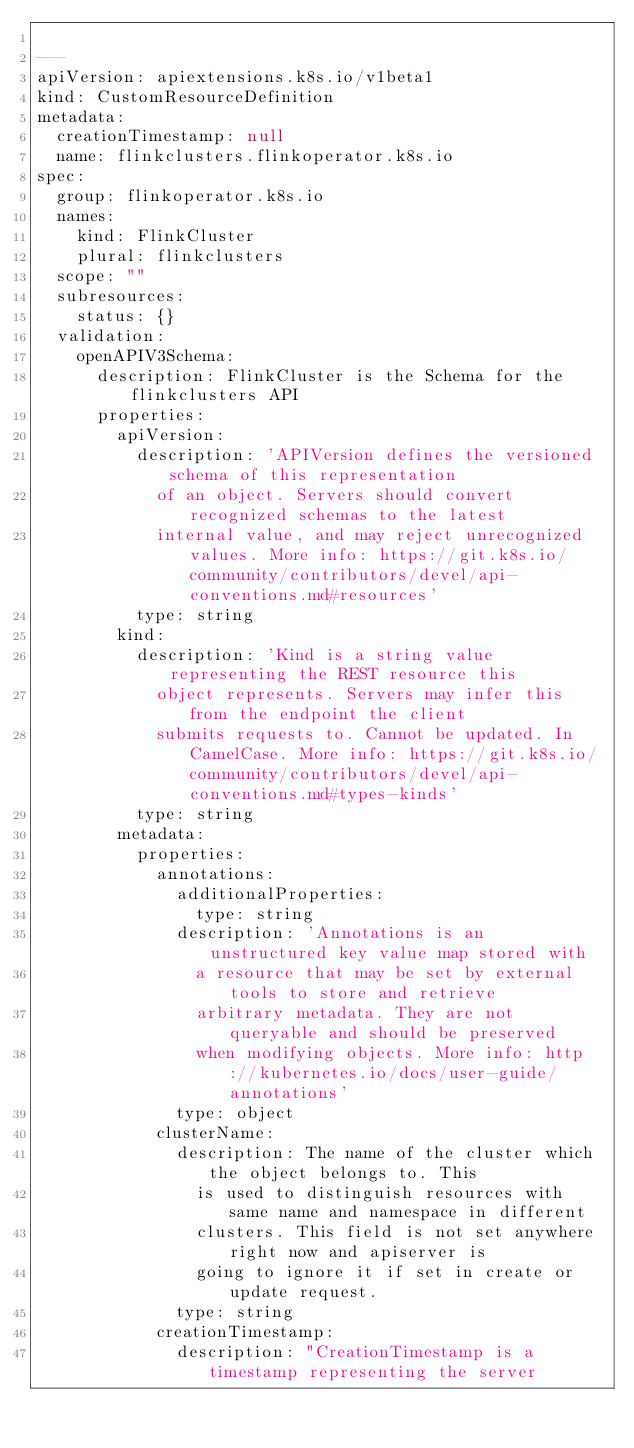<code> <loc_0><loc_0><loc_500><loc_500><_YAML_>
---
apiVersion: apiextensions.k8s.io/v1beta1
kind: CustomResourceDefinition
metadata:
  creationTimestamp: null
  name: flinkclusters.flinkoperator.k8s.io
spec:
  group: flinkoperator.k8s.io
  names:
    kind: FlinkCluster
    plural: flinkclusters
  scope: ""
  subresources:
    status: {}
  validation:
    openAPIV3Schema:
      description: FlinkCluster is the Schema for the flinkclusters API
      properties:
        apiVersion:
          description: 'APIVersion defines the versioned schema of this representation
            of an object. Servers should convert recognized schemas to the latest
            internal value, and may reject unrecognized values. More info: https://git.k8s.io/community/contributors/devel/api-conventions.md#resources'
          type: string
        kind:
          description: 'Kind is a string value representing the REST resource this
            object represents. Servers may infer this from the endpoint the client
            submits requests to. Cannot be updated. In CamelCase. More info: https://git.k8s.io/community/contributors/devel/api-conventions.md#types-kinds'
          type: string
        metadata:
          properties:
            annotations:
              additionalProperties:
                type: string
              description: 'Annotations is an unstructured key value map stored with
                a resource that may be set by external tools to store and retrieve
                arbitrary metadata. They are not queryable and should be preserved
                when modifying objects. More info: http://kubernetes.io/docs/user-guide/annotations'
              type: object
            clusterName:
              description: The name of the cluster which the object belongs to. This
                is used to distinguish resources with same name and namespace in different
                clusters. This field is not set anywhere right now and apiserver is
                going to ignore it if set in create or update request.
              type: string
            creationTimestamp:
              description: "CreationTimestamp is a timestamp representing the server</code> 